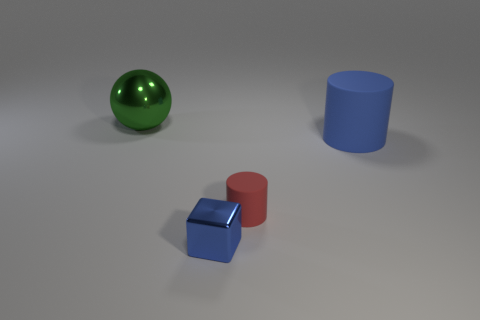Add 1 blue rubber cylinders. How many objects exist? 5 Subtract all spheres. Subtract all blue rubber things. How many objects are left? 2 Add 2 big spheres. How many big spheres are left? 3 Add 3 tiny brown spheres. How many tiny brown spheres exist? 3 Subtract 0 yellow cylinders. How many objects are left? 4 Subtract all blocks. How many objects are left? 3 